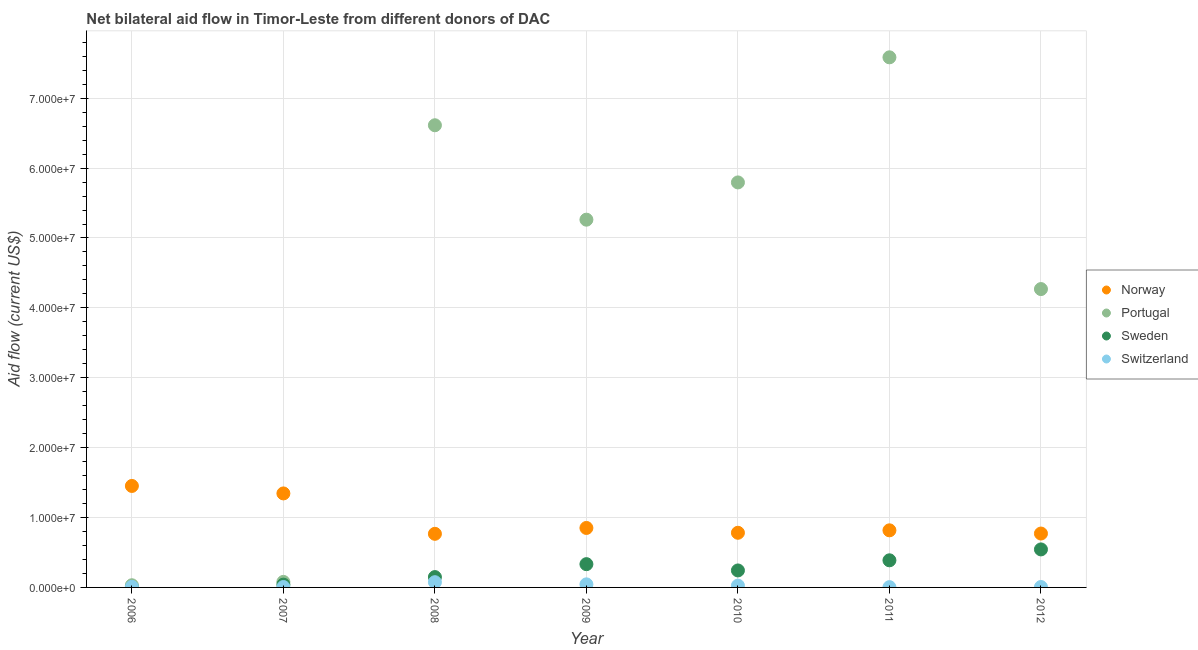What is the amount of aid given by norway in 2012?
Ensure brevity in your answer.  7.71e+06. Across all years, what is the maximum amount of aid given by portugal?
Your answer should be very brief. 7.58e+07. Across all years, what is the minimum amount of aid given by sweden?
Offer a very short reply. 10000. In which year was the amount of aid given by portugal minimum?
Provide a short and direct response. 2006. What is the total amount of aid given by norway in the graph?
Provide a succinct answer. 6.78e+07. What is the difference between the amount of aid given by portugal in 2007 and that in 2012?
Keep it short and to the point. -4.19e+07. What is the difference between the amount of aid given by switzerland in 2006 and the amount of aid given by portugal in 2009?
Ensure brevity in your answer.  -5.25e+07. What is the average amount of aid given by portugal per year?
Your answer should be very brief. 4.23e+07. In the year 2010, what is the difference between the amount of aid given by sweden and amount of aid given by norway?
Provide a short and direct response. -5.39e+06. What is the ratio of the amount of aid given by switzerland in 2011 to that in 2012?
Provide a succinct answer. 0.67. What is the difference between the highest and the second highest amount of aid given by norway?
Offer a terse response. 1.07e+06. What is the difference between the highest and the lowest amount of aid given by switzerland?
Give a very brief answer. 7.10e+05. In how many years, is the amount of aid given by switzerland greater than the average amount of aid given by switzerland taken over all years?
Make the answer very short. 3. Is it the case that in every year, the sum of the amount of aid given by norway and amount of aid given by portugal is greater than the amount of aid given by sweden?
Make the answer very short. Yes. What is the difference between two consecutive major ticks on the Y-axis?
Your response must be concise. 1.00e+07. Does the graph contain grids?
Make the answer very short. Yes. Where does the legend appear in the graph?
Give a very brief answer. Center right. How many legend labels are there?
Give a very brief answer. 4. What is the title of the graph?
Give a very brief answer. Net bilateral aid flow in Timor-Leste from different donors of DAC. What is the label or title of the Y-axis?
Your answer should be compact. Aid flow (current US$). What is the Aid flow (current US$) in Norway in 2006?
Your answer should be very brief. 1.45e+07. What is the Aid flow (current US$) of Sweden in 2006?
Your answer should be compact. 10000. What is the Aid flow (current US$) in Switzerland in 2006?
Provide a short and direct response. 9.00e+04. What is the Aid flow (current US$) in Norway in 2007?
Offer a very short reply. 1.34e+07. What is the Aid flow (current US$) in Portugal in 2007?
Provide a succinct answer. 7.90e+05. What is the Aid flow (current US$) of Switzerland in 2007?
Keep it short and to the point. 6.00e+04. What is the Aid flow (current US$) of Norway in 2008?
Your answer should be very brief. 7.67e+06. What is the Aid flow (current US$) of Portugal in 2008?
Make the answer very short. 6.61e+07. What is the Aid flow (current US$) in Sweden in 2008?
Offer a terse response. 1.48e+06. What is the Aid flow (current US$) in Switzerland in 2008?
Your answer should be compact. 7.50e+05. What is the Aid flow (current US$) of Norway in 2009?
Ensure brevity in your answer.  8.51e+06. What is the Aid flow (current US$) in Portugal in 2009?
Offer a very short reply. 5.26e+07. What is the Aid flow (current US$) of Sweden in 2009?
Keep it short and to the point. 3.33e+06. What is the Aid flow (current US$) of Switzerland in 2009?
Provide a succinct answer. 4.40e+05. What is the Aid flow (current US$) in Norway in 2010?
Keep it short and to the point. 7.82e+06. What is the Aid flow (current US$) in Portugal in 2010?
Offer a very short reply. 5.80e+07. What is the Aid flow (current US$) in Sweden in 2010?
Your response must be concise. 2.43e+06. What is the Aid flow (current US$) in Norway in 2011?
Provide a short and direct response. 8.17e+06. What is the Aid flow (current US$) in Portugal in 2011?
Your answer should be very brief. 7.58e+07. What is the Aid flow (current US$) in Sweden in 2011?
Your response must be concise. 3.88e+06. What is the Aid flow (current US$) of Switzerland in 2011?
Your answer should be compact. 4.00e+04. What is the Aid flow (current US$) in Norway in 2012?
Offer a terse response. 7.71e+06. What is the Aid flow (current US$) of Portugal in 2012?
Make the answer very short. 4.27e+07. What is the Aid flow (current US$) in Sweden in 2012?
Offer a terse response. 5.44e+06. Across all years, what is the maximum Aid flow (current US$) of Norway?
Offer a terse response. 1.45e+07. Across all years, what is the maximum Aid flow (current US$) of Portugal?
Offer a terse response. 7.58e+07. Across all years, what is the maximum Aid flow (current US$) in Sweden?
Make the answer very short. 5.44e+06. Across all years, what is the maximum Aid flow (current US$) of Switzerland?
Give a very brief answer. 7.50e+05. Across all years, what is the minimum Aid flow (current US$) in Norway?
Make the answer very short. 7.67e+06. Across all years, what is the minimum Aid flow (current US$) in Portugal?
Provide a short and direct response. 3.10e+05. Across all years, what is the minimum Aid flow (current US$) of Sweden?
Offer a very short reply. 10000. What is the total Aid flow (current US$) in Norway in the graph?
Offer a terse response. 6.78e+07. What is the total Aid flow (current US$) in Portugal in the graph?
Keep it short and to the point. 2.96e+08. What is the total Aid flow (current US$) of Sweden in the graph?
Offer a very short reply. 1.70e+07. What is the total Aid flow (current US$) of Switzerland in the graph?
Offer a terse response. 1.70e+06. What is the difference between the Aid flow (current US$) in Norway in 2006 and that in 2007?
Give a very brief answer. 1.07e+06. What is the difference between the Aid flow (current US$) in Portugal in 2006 and that in 2007?
Your response must be concise. -4.80e+05. What is the difference between the Aid flow (current US$) of Sweden in 2006 and that in 2007?
Provide a short and direct response. -3.90e+05. What is the difference between the Aid flow (current US$) of Norway in 2006 and that in 2008?
Your answer should be compact. 6.85e+06. What is the difference between the Aid flow (current US$) in Portugal in 2006 and that in 2008?
Keep it short and to the point. -6.58e+07. What is the difference between the Aid flow (current US$) of Sweden in 2006 and that in 2008?
Provide a succinct answer. -1.47e+06. What is the difference between the Aid flow (current US$) in Switzerland in 2006 and that in 2008?
Your response must be concise. -6.60e+05. What is the difference between the Aid flow (current US$) in Norway in 2006 and that in 2009?
Provide a succinct answer. 6.01e+06. What is the difference between the Aid flow (current US$) in Portugal in 2006 and that in 2009?
Your response must be concise. -5.23e+07. What is the difference between the Aid flow (current US$) of Sweden in 2006 and that in 2009?
Offer a very short reply. -3.32e+06. What is the difference between the Aid flow (current US$) in Switzerland in 2006 and that in 2009?
Ensure brevity in your answer.  -3.50e+05. What is the difference between the Aid flow (current US$) in Norway in 2006 and that in 2010?
Offer a very short reply. 6.70e+06. What is the difference between the Aid flow (current US$) in Portugal in 2006 and that in 2010?
Offer a very short reply. -5.76e+07. What is the difference between the Aid flow (current US$) in Sweden in 2006 and that in 2010?
Your response must be concise. -2.42e+06. What is the difference between the Aid flow (current US$) in Switzerland in 2006 and that in 2010?
Your answer should be compact. -1.70e+05. What is the difference between the Aid flow (current US$) in Norway in 2006 and that in 2011?
Your answer should be very brief. 6.35e+06. What is the difference between the Aid flow (current US$) in Portugal in 2006 and that in 2011?
Your response must be concise. -7.55e+07. What is the difference between the Aid flow (current US$) of Sweden in 2006 and that in 2011?
Give a very brief answer. -3.87e+06. What is the difference between the Aid flow (current US$) of Switzerland in 2006 and that in 2011?
Keep it short and to the point. 5.00e+04. What is the difference between the Aid flow (current US$) of Norway in 2006 and that in 2012?
Your response must be concise. 6.81e+06. What is the difference between the Aid flow (current US$) in Portugal in 2006 and that in 2012?
Your answer should be very brief. -4.24e+07. What is the difference between the Aid flow (current US$) of Sweden in 2006 and that in 2012?
Give a very brief answer. -5.43e+06. What is the difference between the Aid flow (current US$) in Switzerland in 2006 and that in 2012?
Your answer should be very brief. 3.00e+04. What is the difference between the Aid flow (current US$) in Norway in 2007 and that in 2008?
Make the answer very short. 5.78e+06. What is the difference between the Aid flow (current US$) in Portugal in 2007 and that in 2008?
Offer a very short reply. -6.53e+07. What is the difference between the Aid flow (current US$) in Sweden in 2007 and that in 2008?
Offer a terse response. -1.08e+06. What is the difference between the Aid flow (current US$) of Switzerland in 2007 and that in 2008?
Keep it short and to the point. -6.90e+05. What is the difference between the Aid flow (current US$) in Norway in 2007 and that in 2009?
Provide a succinct answer. 4.94e+06. What is the difference between the Aid flow (current US$) in Portugal in 2007 and that in 2009?
Give a very brief answer. -5.18e+07. What is the difference between the Aid flow (current US$) in Sweden in 2007 and that in 2009?
Give a very brief answer. -2.93e+06. What is the difference between the Aid flow (current US$) of Switzerland in 2007 and that in 2009?
Offer a very short reply. -3.80e+05. What is the difference between the Aid flow (current US$) in Norway in 2007 and that in 2010?
Provide a short and direct response. 5.63e+06. What is the difference between the Aid flow (current US$) in Portugal in 2007 and that in 2010?
Your answer should be compact. -5.72e+07. What is the difference between the Aid flow (current US$) of Sweden in 2007 and that in 2010?
Your answer should be compact. -2.03e+06. What is the difference between the Aid flow (current US$) of Switzerland in 2007 and that in 2010?
Offer a very short reply. -2.00e+05. What is the difference between the Aid flow (current US$) in Norway in 2007 and that in 2011?
Your answer should be very brief. 5.28e+06. What is the difference between the Aid flow (current US$) in Portugal in 2007 and that in 2011?
Offer a very short reply. -7.51e+07. What is the difference between the Aid flow (current US$) in Sweden in 2007 and that in 2011?
Your answer should be compact. -3.48e+06. What is the difference between the Aid flow (current US$) in Switzerland in 2007 and that in 2011?
Make the answer very short. 2.00e+04. What is the difference between the Aid flow (current US$) in Norway in 2007 and that in 2012?
Make the answer very short. 5.74e+06. What is the difference between the Aid flow (current US$) in Portugal in 2007 and that in 2012?
Make the answer very short. -4.19e+07. What is the difference between the Aid flow (current US$) of Sweden in 2007 and that in 2012?
Give a very brief answer. -5.04e+06. What is the difference between the Aid flow (current US$) of Norway in 2008 and that in 2009?
Your answer should be compact. -8.40e+05. What is the difference between the Aid flow (current US$) of Portugal in 2008 and that in 2009?
Your response must be concise. 1.35e+07. What is the difference between the Aid flow (current US$) of Sweden in 2008 and that in 2009?
Give a very brief answer. -1.85e+06. What is the difference between the Aid flow (current US$) of Switzerland in 2008 and that in 2009?
Ensure brevity in your answer.  3.10e+05. What is the difference between the Aid flow (current US$) in Portugal in 2008 and that in 2010?
Offer a terse response. 8.18e+06. What is the difference between the Aid flow (current US$) of Sweden in 2008 and that in 2010?
Offer a terse response. -9.50e+05. What is the difference between the Aid flow (current US$) in Switzerland in 2008 and that in 2010?
Provide a short and direct response. 4.90e+05. What is the difference between the Aid flow (current US$) in Norway in 2008 and that in 2011?
Offer a very short reply. -5.00e+05. What is the difference between the Aid flow (current US$) in Portugal in 2008 and that in 2011?
Provide a succinct answer. -9.72e+06. What is the difference between the Aid flow (current US$) in Sweden in 2008 and that in 2011?
Offer a very short reply. -2.40e+06. What is the difference between the Aid flow (current US$) in Switzerland in 2008 and that in 2011?
Offer a terse response. 7.10e+05. What is the difference between the Aid flow (current US$) in Norway in 2008 and that in 2012?
Offer a terse response. -4.00e+04. What is the difference between the Aid flow (current US$) in Portugal in 2008 and that in 2012?
Keep it short and to the point. 2.34e+07. What is the difference between the Aid flow (current US$) of Sweden in 2008 and that in 2012?
Your answer should be very brief. -3.96e+06. What is the difference between the Aid flow (current US$) of Switzerland in 2008 and that in 2012?
Offer a terse response. 6.90e+05. What is the difference between the Aid flow (current US$) of Norway in 2009 and that in 2010?
Ensure brevity in your answer.  6.90e+05. What is the difference between the Aid flow (current US$) in Portugal in 2009 and that in 2010?
Keep it short and to the point. -5.33e+06. What is the difference between the Aid flow (current US$) in Switzerland in 2009 and that in 2010?
Offer a very short reply. 1.80e+05. What is the difference between the Aid flow (current US$) of Portugal in 2009 and that in 2011?
Offer a very short reply. -2.32e+07. What is the difference between the Aid flow (current US$) in Sweden in 2009 and that in 2011?
Keep it short and to the point. -5.50e+05. What is the difference between the Aid flow (current US$) in Portugal in 2009 and that in 2012?
Offer a very short reply. 9.93e+06. What is the difference between the Aid flow (current US$) of Sweden in 2009 and that in 2012?
Give a very brief answer. -2.11e+06. What is the difference between the Aid flow (current US$) in Switzerland in 2009 and that in 2012?
Your answer should be compact. 3.80e+05. What is the difference between the Aid flow (current US$) in Norway in 2010 and that in 2011?
Keep it short and to the point. -3.50e+05. What is the difference between the Aid flow (current US$) in Portugal in 2010 and that in 2011?
Your answer should be compact. -1.79e+07. What is the difference between the Aid flow (current US$) in Sweden in 2010 and that in 2011?
Your answer should be compact. -1.45e+06. What is the difference between the Aid flow (current US$) of Portugal in 2010 and that in 2012?
Provide a succinct answer. 1.53e+07. What is the difference between the Aid flow (current US$) in Sweden in 2010 and that in 2012?
Ensure brevity in your answer.  -3.01e+06. What is the difference between the Aid flow (current US$) in Switzerland in 2010 and that in 2012?
Provide a succinct answer. 2.00e+05. What is the difference between the Aid flow (current US$) in Portugal in 2011 and that in 2012?
Your answer should be compact. 3.32e+07. What is the difference between the Aid flow (current US$) of Sweden in 2011 and that in 2012?
Provide a succinct answer. -1.56e+06. What is the difference between the Aid flow (current US$) in Switzerland in 2011 and that in 2012?
Give a very brief answer. -2.00e+04. What is the difference between the Aid flow (current US$) in Norway in 2006 and the Aid flow (current US$) in Portugal in 2007?
Your answer should be very brief. 1.37e+07. What is the difference between the Aid flow (current US$) in Norway in 2006 and the Aid flow (current US$) in Sweden in 2007?
Ensure brevity in your answer.  1.41e+07. What is the difference between the Aid flow (current US$) in Norway in 2006 and the Aid flow (current US$) in Switzerland in 2007?
Your response must be concise. 1.45e+07. What is the difference between the Aid flow (current US$) of Portugal in 2006 and the Aid flow (current US$) of Sweden in 2007?
Keep it short and to the point. -9.00e+04. What is the difference between the Aid flow (current US$) of Sweden in 2006 and the Aid flow (current US$) of Switzerland in 2007?
Offer a terse response. -5.00e+04. What is the difference between the Aid flow (current US$) in Norway in 2006 and the Aid flow (current US$) in Portugal in 2008?
Keep it short and to the point. -5.16e+07. What is the difference between the Aid flow (current US$) in Norway in 2006 and the Aid flow (current US$) in Sweden in 2008?
Your response must be concise. 1.30e+07. What is the difference between the Aid flow (current US$) in Norway in 2006 and the Aid flow (current US$) in Switzerland in 2008?
Offer a very short reply. 1.38e+07. What is the difference between the Aid flow (current US$) of Portugal in 2006 and the Aid flow (current US$) of Sweden in 2008?
Offer a very short reply. -1.17e+06. What is the difference between the Aid flow (current US$) of Portugal in 2006 and the Aid flow (current US$) of Switzerland in 2008?
Your response must be concise. -4.40e+05. What is the difference between the Aid flow (current US$) of Sweden in 2006 and the Aid flow (current US$) of Switzerland in 2008?
Provide a succinct answer. -7.40e+05. What is the difference between the Aid flow (current US$) of Norway in 2006 and the Aid flow (current US$) of Portugal in 2009?
Offer a terse response. -3.81e+07. What is the difference between the Aid flow (current US$) of Norway in 2006 and the Aid flow (current US$) of Sweden in 2009?
Your answer should be very brief. 1.12e+07. What is the difference between the Aid flow (current US$) in Norway in 2006 and the Aid flow (current US$) in Switzerland in 2009?
Give a very brief answer. 1.41e+07. What is the difference between the Aid flow (current US$) in Portugal in 2006 and the Aid flow (current US$) in Sweden in 2009?
Your answer should be very brief. -3.02e+06. What is the difference between the Aid flow (current US$) in Portugal in 2006 and the Aid flow (current US$) in Switzerland in 2009?
Your answer should be compact. -1.30e+05. What is the difference between the Aid flow (current US$) in Sweden in 2006 and the Aid flow (current US$) in Switzerland in 2009?
Offer a terse response. -4.30e+05. What is the difference between the Aid flow (current US$) in Norway in 2006 and the Aid flow (current US$) in Portugal in 2010?
Offer a very short reply. -4.34e+07. What is the difference between the Aid flow (current US$) of Norway in 2006 and the Aid flow (current US$) of Sweden in 2010?
Offer a terse response. 1.21e+07. What is the difference between the Aid flow (current US$) in Norway in 2006 and the Aid flow (current US$) in Switzerland in 2010?
Provide a succinct answer. 1.43e+07. What is the difference between the Aid flow (current US$) in Portugal in 2006 and the Aid flow (current US$) in Sweden in 2010?
Your answer should be compact. -2.12e+06. What is the difference between the Aid flow (current US$) of Norway in 2006 and the Aid flow (current US$) of Portugal in 2011?
Offer a terse response. -6.13e+07. What is the difference between the Aid flow (current US$) of Norway in 2006 and the Aid flow (current US$) of Sweden in 2011?
Provide a succinct answer. 1.06e+07. What is the difference between the Aid flow (current US$) in Norway in 2006 and the Aid flow (current US$) in Switzerland in 2011?
Provide a succinct answer. 1.45e+07. What is the difference between the Aid flow (current US$) of Portugal in 2006 and the Aid flow (current US$) of Sweden in 2011?
Your answer should be compact. -3.57e+06. What is the difference between the Aid flow (current US$) of Portugal in 2006 and the Aid flow (current US$) of Switzerland in 2011?
Your answer should be very brief. 2.70e+05. What is the difference between the Aid flow (current US$) in Sweden in 2006 and the Aid flow (current US$) in Switzerland in 2011?
Ensure brevity in your answer.  -3.00e+04. What is the difference between the Aid flow (current US$) in Norway in 2006 and the Aid flow (current US$) in Portugal in 2012?
Offer a very short reply. -2.82e+07. What is the difference between the Aid flow (current US$) of Norway in 2006 and the Aid flow (current US$) of Sweden in 2012?
Offer a very short reply. 9.08e+06. What is the difference between the Aid flow (current US$) in Norway in 2006 and the Aid flow (current US$) in Switzerland in 2012?
Ensure brevity in your answer.  1.45e+07. What is the difference between the Aid flow (current US$) in Portugal in 2006 and the Aid flow (current US$) in Sweden in 2012?
Ensure brevity in your answer.  -5.13e+06. What is the difference between the Aid flow (current US$) in Portugal in 2006 and the Aid flow (current US$) in Switzerland in 2012?
Offer a very short reply. 2.50e+05. What is the difference between the Aid flow (current US$) in Sweden in 2006 and the Aid flow (current US$) in Switzerland in 2012?
Provide a succinct answer. -5.00e+04. What is the difference between the Aid flow (current US$) in Norway in 2007 and the Aid flow (current US$) in Portugal in 2008?
Offer a very short reply. -5.27e+07. What is the difference between the Aid flow (current US$) in Norway in 2007 and the Aid flow (current US$) in Sweden in 2008?
Make the answer very short. 1.20e+07. What is the difference between the Aid flow (current US$) in Norway in 2007 and the Aid flow (current US$) in Switzerland in 2008?
Your answer should be very brief. 1.27e+07. What is the difference between the Aid flow (current US$) in Portugal in 2007 and the Aid flow (current US$) in Sweden in 2008?
Provide a short and direct response. -6.90e+05. What is the difference between the Aid flow (current US$) in Portugal in 2007 and the Aid flow (current US$) in Switzerland in 2008?
Give a very brief answer. 4.00e+04. What is the difference between the Aid flow (current US$) in Sweden in 2007 and the Aid flow (current US$) in Switzerland in 2008?
Provide a short and direct response. -3.50e+05. What is the difference between the Aid flow (current US$) in Norway in 2007 and the Aid flow (current US$) in Portugal in 2009?
Your response must be concise. -3.92e+07. What is the difference between the Aid flow (current US$) in Norway in 2007 and the Aid flow (current US$) in Sweden in 2009?
Keep it short and to the point. 1.01e+07. What is the difference between the Aid flow (current US$) in Norway in 2007 and the Aid flow (current US$) in Switzerland in 2009?
Provide a succinct answer. 1.30e+07. What is the difference between the Aid flow (current US$) of Portugal in 2007 and the Aid flow (current US$) of Sweden in 2009?
Offer a terse response. -2.54e+06. What is the difference between the Aid flow (current US$) of Portugal in 2007 and the Aid flow (current US$) of Switzerland in 2009?
Ensure brevity in your answer.  3.50e+05. What is the difference between the Aid flow (current US$) in Sweden in 2007 and the Aid flow (current US$) in Switzerland in 2009?
Give a very brief answer. -4.00e+04. What is the difference between the Aid flow (current US$) in Norway in 2007 and the Aid flow (current US$) in Portugal in 2010?
Your answer should be very brief. -4.45e+07. What is the difference between the Aid flow (current US$) of Norway in 2007 and the Aid flow (current US$) of Sweden in 2010?
Provide a short and direct response. 1.10e+07. What is the difference between the Aid flow (current US$) of Norway in 2007 and the Aid flow (current US$) of Switzerland in 2010?
Give a very brief answer. 1.32e+07. What is the difference between the Aid flow (current US$) of Portugal in 2007 and the Aid flow (current US$) of Sweden in 2010?
Make the answer very short. -1.64e+06. What is the difference between the Aid flow (current US$) of Portugal in 2007 and the Aid flow (current US$) of Switzerland in 2010?
Provide a succinct answer. 5.30e+05. What is the difference between the Aid flow (current US$) in Sweden in 2007 and the Aid flow (current US$) in Switzerland in 2010?
Make the answer very short. 1.40e+05. What is the difference between the Aid flow (current US$) in Norway in 2007 and the Aid flow (current US$) in Portugal in 2011?
Make the answer very short. -6.24e+07. What is the difference between the Aid flow (current US$) in Norway in 2007 and the Aid flow (current US$) in Sweden in 2011?
Your answer should be compact. 9.57e+06. What is the difference between the Aid flow (current US$) of Norway in 2007 and the Aid flow (current US$) of Switzerland in 2011?
Your answer should be very brief. 1.34e+07. What is the difference between the Aid flow (current US$) in Portugal in 2007 and the Aid flow (current US$) in Sweden in 2011?
Your answer should be very brief. -3.09e+06. What is the difference between the Aid flow (current US$) in Portugal in 2007 and the Aid flow (current US$) in Switzerland in 2011?
Offer a very short reply. 7.50e+05. What is the difference between the Aid flow (current US$) of Norway in 2007 and the Aid flow (current US$) of Portugal in 2012?
Your answer should be compact. -2.92e+07. What is the difference between the Aid flow (current US$) of Norway in 2007 and the Aid flow (current US$) of Sweden in 2012?
Give a very brief answer. 8.01e+06. What is the difference between the Aid flow (current US$) of Norway in 2007 and the Aid flow (current US$) of Switzerland in 2012?
Offer a terse response. 1.34e+07. What is the difference between the Aid flow (current US$) of Portugal in 2007 and the Aid flow (current US$) of Sweden in 2012?
Offer a very short reply. -4.65e+06. What is the difference between the Aid flow (current US$) in Portugal in 2007 and the Aid flow (current US$) in Switzerland in 2012?
Your answer should be compact. 7.30e+05. What is the difference between the Aid flow (current US$) of Norway in 2008 and the Aid flow (current US$) of Portugal in 2009?
Give a very brief answer. -4.50e+07. What is the difference between the Aid flow (current US$) of Norway in 2008 and the Aid flow (current US$) of Sweden in 2009?
Your answer should be compact. 4.34e+06. What is the difference between the Aid flow (current US$) in Norway in 2008 and the Aid flow (current US$) in Switzerland in 2009?
Ensure brevity in your answer.  7.23e+06. What is the difference between the Aid flow (current US$) in Portugal in 2008 and the Aid flow (current US$) in Sweden in 2009?
Provide a succinct answer. 6.28e+07. What is the difference between the Aid flow (current US$) in Portugal in 2008 and the Aid flow (current US$) in Switzerland in 2009?
Make the answer very short. 6.57e+07. What is the difference between the Aid flow (current US$) of Sweden in 2008 and the Aid flow (current US$) of Switzerland in 2009?
Ensure brevity in your answer.  1.04e+06. What is the difference between the Aid flow (current US$) in Norway in 2008 and the Aid flow (current US$) in Portugal in 2010?
Make the answer very short. -5.03e+07. What is the difference between the Aid flow (current US$) of Norway in 2008 and the Aid flow (current US$) of Sweden in 2010?
Keep it short and to the point. 5.24e+06. What is the difference between the Aid flow (current US$) of Norway in 2008 and the Aid flow (current US$) of Switzerland in 2010?
Ensure brevity in your answer.  7.41e+06. What is the difference between the Aid flow (current US$) of Portugal in 2008 and the Aid flow (current US$) of Sweden in 2010?
Provide a succinct answer. 6.37e+07. What is the difference between the Aid flow (current US$) in Portugal in 2008 and the Aid flow (current US$) in Switzerland in 2010?
Make the answer very short. 6.59e+07. What is the difference between the Aid flow (current US$) in Sweden in 2008 and the Aid flow (current US$) in Switzerland in 2010?
Offer a terse response. 1.22e+06. What is the difference between the Aid flow (current US$) in Norway in 2008 and the Aid flow (current US$) in Portugal in 2011?
Keep it short and to the point. -6.82e+07. What is the difference between the Aid flow (current US$) in Norway in 2008 and the Aid flow (current US$) in Sweden in 2011?
Provide a succinct answer. 3.79e+06. What is the difference between the Aid flow (current US$) of Norway in 2008 and the Aid flow (current US$) of Switzerland in 2011?
Ensure brevity in your answer.  7.63e+06. What is the difference between the Aid flow (current US$) in Portugal in 2008 and the Aid flow (current US$) in Sweden in 2011?
Your answer should be compact. 6.22e+07. What is the difference between the Aid flow (current US$) in Portugal in 2008 and the Aid flow (current US$) in Switzerland in 2011?
Offer a very short reply. 6.61e+07. What is the difference between the Aid flow (current US$) of Sweden in 2008 and the Aid flow (current US$) of Switzerland in 2011?
Offer a very short reply. 1.44e+06. What is the difference between the Aid flow (current US$) of Norway in 2008 and the Aid flow (current US$) of Portugal in 2012?
Offer a terse response. -3.50e+07. What is the difference between the Aid flow (current US$) in Norway in 2008 and the Aid flow (current US$) in Sweden in 2012?
Your response must be concise. 2.23e+06. What is the difference between the Aid flow (current US$) in Norway in 2008 and the Aid flow (current US$) in Switzerland in 2012?
Give a very brief answer. 7.61e+06. What is the difference between the Aid flow (current US$) in Portugal in 2008 and the Aid flow (current US$) in Sweden in 2012?
Your answer should be compact. 6.07e+07. What is the difference between the Aid flow (current US$) of Portugal in 2008 and the Aid flow (current US$) of Switzerland in 2012?
Make the answer very short. 6.61e+07. What is the difference between the Aid flow (current US$) in Sweden in 2008 and the Aid flow (current US$) in Switzerland in 2012?
Offer a very short reply. 1.42e+06. What is the difference between the Aid flow (current US$) in Norway in 2009 and the Aid flow (current US$) in Portugal in 2010?
Ensure brevity in your answer.  -4.94e+07. What is the difference between the Aid flow (current US$) of Norway in 2009 and the Aid flow (current US$) of Sweden in 2010?
Provide a short and direct response. 6.08e+06. What is the difference between the Aid flow (current US$) of Norway in 2009 and the Aid flow (current US$) of Switzerland in 2010?
Provide a succinct answer. 8.25e+06. What is the difference between the Aid flow (current US$) in Portugal in 2009 and the Aid flow (current US$) in Sweden in 2010?
Your response must be concise. 5.02e+07. What is the difference between the Aid flow (current US$) of Portugal in 2009 and the Aid flow (current US$) of Switzerland in 2010?
Your answer should be very brief. 5.24e+07. What is the difference between the Aid flow (current US$) in Sweden in 2009 and the Aid flow (current US$) in Switzerland in 2010?
Provide a succinct answer. 3.07e+06. What is the difference between the Aid flow (current US$) in Norway in 2009 and the Aid flow (current US$) in Portugal in 2011?
Your answer should be very brief. -6.73e+07. What is the difference between the Aid flow (current US$) of Norway in 2009 and the Aid flow (current US$) of Sweden in 2011?
Give a very brief answer. 4.63e+06. What is the difference between the Aid flow (current US$) of Norway in 2009 and the Aid flow (current US$) of Switzerland in 2011?
Offer a very short reply. 8.47e+06. What is the difference between the Aid flow (current US$) in Portugal in 2009 and the Aid flow (current US$) in Sweden in 2011?
Give a very brief answer. 4.87e+07. What is the difference between the Aid flow (current US$) in Portugal in 2009 and the Aid flow (current US$) in Switzerland in 2011?
Offer a very short reply. 5.26e+07. What is the difference between the Aid flow (current US$) of Sweden in 2009 and the Aid flow (current US$) of Switzerland in 2011?
Give a very brief answer. 3.29e+06. What is the difference between the Aid flow (current US$) in Norway in 2009 and the Aid flow (current US$) in Portugal in 2012?
Your answer should be compact. -3.42e+07. What is the difference between the Aid flow (current US$) of Norway in 2009 and the Aid flow (current US$) of Sweden in 2012?
Provide a short and direct response. 3.07e+06. What is the difference between the Aid flow (current US$) in Norway in 2009 and the Aid flow (current US$) in Switzerland in 2012?
Offer a terse response. 8.45e+06. What is the difference between the Aid flow (current US$) in Portugal in 2009 and the Aid flow (current US$) in Sweden in 2012?
Ensure brevity in your answer.  4.72e+07. What is the difference between the Aid flow (current US$) of Portugal in 2009 and the Aid flow (current US$) of Switzerland in 2012?
Your answer should be compact. 5.26e+07. What is the difference between the Aid flow (current US$) in Sweden in 2009 and the Aid flow (current US$) in Switzerland in 2012?
Provide a short and direct response. 3.27e+06. What is the difference between the Aid flow (current US$) in Norway in 2010 and the Aid flow (current US$) in Portugal in 2011?
Your answer should be compact. -6.80e+07. What is the difference between the Aid flow (current US$) in Norway in 2010 and the Aid flow (current US$) in Sweden in 2011?
Your answer should be very brief. 3.94e+06. What is the difference between the Aid flow (current US$) of Norway in 2010 and the Aid flow (current US$) of Switzerland in 2011?
Make the answer very short. 7.78e+06. What is the difference between the Aid flow (current US$) in Portugal in 2010 and the Aid flow (current US$) in Sweden in 2011?
Offer a very short reply. 5.41e+07. What is the difference between the Aid flow (current US$) in Portugal in 2010 and the Aid flow (current US$) in Switzerland in 2011?
Offer a terse response. 5.79e+07. What is the difference between the Aid flow (current US$) of Sweden in 2010 and the Aid flow (current US$) of Switzerland in 2011?
Provide a short and direct response. 2.39e+06. What is the difference between the Aid flow (current US$) in Norway in 2010 and the Aid flow (current US$) in Portugal in 2012?
Provide a succinct answer. -3.49e+07. What is the difference between the Aid flow (current US$) of Norway in 2010 and the Aid flow (current US$) of Sweden in 2012?
Offer a terse response. 2.38e+06. What is the difference between the Aid flow (current US$) of Norway in 2010 and the Aid flow (current US$) of Switzerland in 2012?
Offer a very short reply. 7.76e+06. What is the difference between the Aid flow (current US$) in Portugal in 2010 and the Aid flow (current US$) in Sweden in 2012?
Provide a succinct answer. 5.25e+07. What is the difference between the Aid flow (current US$) of Portugal in 2010 and the Aid flow (current US$) of Switzerland in 2012?
Your response must be concise. 5.79e+07. What is the difference between the Aid flow (current US$) of Sweden in 2010 and the Aid flow (current US$) of Switzerland in 2012?
Make the answer very short. 2.37e+06. What is the difference between the Aid flow (current US$) of Norway in 2011 and the Aid flow (current US$) of Portugal in 2012?
Make the answer very short. -3.45e+07. What is the difference between the Aid flow (current US$) of Norway in 2011 and the Aid flow (current US$) of Sweden in 2012?
Offer a terse response. 2.73e+06. What is the difference between the Aid flow (current US$) in Norway in 2011 and the Aid flow (current US$) in Switzerland in 2012?
Provide a succinct answer. 8.11e+06. What is the difference between the Aid flow (current US$) in Portugal in 2011 and the Aid flow (current US$) in Sweden in 2012?
Your answer should be compact. 7.04e+07. What is the difference between the Aid flow (current US$) in Portugal in 2011 and the Aid flow (current US$) in Switzerland in 2012?
Ensure brevity in your answer.  7.58e+07. What is the difference between the Aid flow (current US$) of Sweden in 2011 and the Aid flow (current US$) of Switzerland in 2012?
Your response must be concise. 3.82e+06. What is the average Aid flow (current US$) of Norway per year?
Provide a succinct answer. 9.69e+06. What is the average Aid flow (current US$) in Portugal per year?
Provide a short and direct response. 4.23e+07. What is the average Aid flow (current US$) in Sweden per year?
Your answer should be compact. 2.42e+06. What is the average Aid flow (current US$) of Switzerland per year?
Keep it short and to the point. 2.43e+05. In the year 2006, what is the difference between the Aid flow (current US$) of Norway and Aid flow (current US$) of Portugal?
Your response must be concise. 1.42e+07. In the year 2006, what is the difference between the Aid flow (current US$) of Norway and Aid flow (current US$) of Sweden?
Offer a terse response. 1.45e+07. In the year 2006, what is the difference between the Aid flow (current US$) of Norway and Aid flow (current US$) of Switzerland?
Provide a short and direct response. 1.44e+07. In the year 2006, what is the difference between the Aid flow (current US$) of Portugal and Aid flow (current US$) of Sweden?
Provide a short and direct response. 3.00e+05. In the year 2006, what is the difference between the Aid flow (current US$) in Portugal and Aid flow (current US$) in Switzerland?
Ensure brevity in your answer.  2.20e+05. In the year 2007, what is the difference between the Aid flow (current US$) in Norway and Aid flow (current US$) in Portugal?
Your answer should be very brief. 1.27e+07. In the year 2007, what is the difference between the Aid flow (current US$) of Norway and Aid flow (current US$) of Sweden?
Ensure brevity in your answer.  1.30e+07. In the year 2007, what is the difference between the Aid flow (current US$) in Norway and Aid flow (current US$) in Switzerland?
Give a very brief answer. 1.34e+07. In the year 2007, what is the difference between the Aid flow (current US$) in Portugal and Aid flow (current US$) in Switzerland?
Provide a succinct answer. 7.30e+05. In the year 2008, what is the difference between the Aid flow (current US$) of Norway and Aid flow (current US$) of Portugal?
Give a very brief answer. -5.85e+07. In the year 2008, what is the difference between the Aid flow (current US$) of Norway and Aid flow (current US$) of Sweden?
Keep it short and to the point. 6.19e+06. In the year 2008, what is the difference between the Aid flow (current US$) of Norway and Aid flow (current US$) of Switzerland?
Provide a succinct answer. 6.92e+06. In the year 2008, what is the difference between the Aid flow (current US$) of Portugal and Aid flow (current US$) of Sweden?
Your response must be concise. 6.46e+07. In the year 2008, what is the difference between the Aid flow (current US$) of Portugal and Aid flow (current US$) of Switzerland?
Your answer should be very brief. 6.54e+07. In the year 2008, what is the difference between the Aid flow (current US$) in Sweden and Aid flow (current US$) in Switzerland?
Ensure brevity in your answer.  7.30e+05. In the year 2009, what is the difference between the Aid flow (current US$) in Norway and Aid flow (current US$) in Portugal?
Provide a short and direct response. -4.41e+07. In the year 2009, what is the difference between the Aid flow (current US$) in Norway and Aid flow (current US$) in Sweden?
Your answer should be very brief. 5.18e+06. In the year 2009, what is the difference between the Aid flow (current US$) in Norway and Aid flow (current US$) in Switzerland?
Ensure brevity in your answer.  8.07e+06. In the year 2009, what is the difference between the Aid flow (current US$) in Portugal and Aid flow (current US$) in Sweden?
Keep it short and to the point. 4.93e+07. In the year 2009, what is the difference between the Aid flow (current US$) of Portugal and Aid flow (current US$) of Switzerland?
Keep it short and to the point. 5.22e+07. In the year 2009, what is the difference between the Aid flow (current US$) in Sweden and Aid flow (current US$) in Switzerland?
Offer a very short reply. 2.89e+06. In the year 2010, what is the difference between the Aid flow (current US$) in Norway and Aid flow (current US$) in Portugal?
Provide a short and direct response. -5.01e+07. In the year 2010, what is the difference between the Aid flow (current US$) of Norway and Aid flow (current US$) of Sweden?
Offer a terse response. 5.39e+06. In the year 2010, what is the difference between the Aid flow (current US$) of Norway and Aid flow (current US$) of Switzerland?
Make the answer very short. 7.56e+06. In the year 2010, what is the difference between the Aid flow (current US$) in Portugal and Aid flow (current US$) in Sweden?
Keep it short and to the point. 5.55e+07. In the year 2010, what is the difference between the Aid flow (current US$) in Portugal and Aid flow (current US$) in Switzerland?
Your answer should be compact. 5.77e+07. In the year 2010, what is the difference between the Aid flow (current US$) of Sweden and Aid flow (current US$) of Switzerland?
Ensure brevity in your answer.  2.17e+06. In the year 2011, what is the difference between the Aid flow (current US$) of Norway and Aid flow (current US$) of Portugal?
Give a very brief answer. -6.77e+07. In the year 2011, what is the difference between the Aid flow (current US$) in Norway and Aid flow (current US$) in Sweden?
Offer a terse response. 4.29e+06. In the year 2011, what is the difference between the Aid flow (current US$) in Norway and Aid flow (current US$) in Switzerland?
Keep it short and to the point. 8.13e+06. In the year 2011, what is the difference between the Aid flow (current US$) of Portugal and Aid flow (current US$) of Sweden?
Make the answer very short. 7.20e+07. In the year 2011, what is the difference between the Aid flow (current US$) of Portugal and Aid flow (current US$) of Switzerland?
Offer a terse response. 7.58e+07. In the year 2011, what is the difference between the Aid flow (current US$) of Sweden and Aid flow (current US$) of Switzerland?
Give a very brief answer. 3.84e+06. In the year 2012, what is the difference between the Aid flow (current US$) of Norway and Aid flow (current US$) of Portugal?
Give a very brief answer. -3.50e+07. In the year 2012, what is the difference between the Aid flow (current US$) of Norway and Aid flow (current US$) of Sweden?
Provide a succinct answer. 2.27e+06. In the year 2012, what is the difference between the Aid flow (current US$) in Norway and Aid flow (current US$) in Switzerland?
Provide a short and direct response. 7.65e+06. In the year 2012, what is the difference between the Aid flow (current US$) in Portugal and Aid flow (current US$) in Sweden?
Offer a terse response. 3.72e+07. In the year 2012, what is the difference between the Aid flow (current US$) in Portugal and Aid flow (current US$) in Switzerland?
Provide a succinct answer. 4.26e+07. In the year 2012, what is the difference between the Aid flow (current US$) in Sweden and Aid flow (current US$) in Switzerland?
Offer a very short reply. 5.38e+06. What is the ratio of the Aid flow (current US$) in Norway in 2006 to that in 2007?
Offer a terse response. 1.08. What is the ratio of the Aid flow (current US$) in Portugal in 2006 to that in 2007?
Make the answer very short. 0.39. What is the ratio of the Aid flow (current US$) of Sweden in 2006 to that in 2007?
Your answer should be compact. 0.03. What is the ratio of the Aid flow (current US$) of Norway in 2006 to that in 2008?
Ensure brevity in your answer.  1.89. What is the ratio of the Aid flow (current US$) of Portugal in 2006 to that in 2008?
Give a very brief answer. 0. What is the ratio of the Aid flow (current US$) in Sweden in 2006 to that in 2008?
Make the answer very short. 0.01. What is the ratio of the Aid flow (current US$) of Switzerland in 2006 to that in 2008?
Give a very brief answer. 0.12. What is the ratio of the Aid flow (current US$) in Norway in 2006 to that in 2009?
Make the answer very short. 1.71. What is the ratio of the Aid flow (current US$) of Portugal in 2006 to that in 2009?
Offer a very short reply. 0.01. What is the ratio of the Aid flow (current US$) of Sweden in 2006 to that in 2009?
Give a very brief answer. 0. What is the ratio of the Aid flow (current US$) in Switzerland in 2006 to that in 2009?
Your answer should be compact. 0.2. What is the ratio of the Aid flow (current US$) of Norway in 2006 to that in 2010?
Offer a very short reply. 1.86. What is the ratio of the Aid flow (current US$) in Portugal in 2006 to that in 2010?
Provide a short and direct response. 0.01. What is the ratio of the Aid flow (current US$) in Sweden in 2006 to that in 2010?
Ensure brevity in your answer.  0. What is the ratio of the Aid flow (current US$) in Switzerland in 2006 to that in 2010?
Give a very brief answer. 0.35. What is the ratio of the Aid flow (current US$) of Norway in 2006 to that in 2011?
Offer a very short reply. 1.78. What is the ratio of the Aid flow (current US$) of Portugal in 2006 to that in 2011?
Give a very brief answer. 0. What is the ratio of the Aid flow (current US$) of Sweden in 2006 to that in 2011?
Provide a succinct answer. 0. What is the ratio of the Aid flow (current US$) of Switzerland in 2006 to that in 2011?
Provide a succinct answer. 2.25. What is the ratio of the Aid flow (current US$) of Norway in 2006 to that in 2012?
Offer a terse response. 1.88. What is the ratio of the Aid flow (current US$) of Portugal in 2006 to that in 2012?
Your answer should be very brief. 0.01. What is the ratio of the Aid flow (current US$) in Sweden in 2006 to that in 2012?
Your answer should be very brief. 0. What is the ratio of the Aid flow (current US$) of Switzerland in 2006 to that in 2012?
Your answer should be very brief. 1.5. What is the ratio of the Aid flow (current US$) in Norway in 2007 to that in 2008?
Provide a short and direct response. 1.75. What is the ratio of the Aid flow (current US$) of Portugal in 2007 to that in 2008?
Your answer should be very brief. 0.01. What is the ratio of the Aid flow (current US$) in Sweden in 2007 to that in 2008?
Your answer should be compact. 0.27. What is the ratio of the Aid flow (current US$) in Switzerland in 2007 to that in 2008?
Keep it short and to the point. 0.08. What is the ratio of the Aid flow (current US$) of Norway in 2007 to that in 2009?
Ensure brevity in your answer.  1.58. What is the ratio of the Aid flow (current US$) in Portugal in 2007 to that in 2009?
Provide a short and direct response. 0.01. What is the ratio of the Aid flow (current US$) in Sweden in 2007 to that in 2009?
Give a very brief answer. 0.12. What is the ratio of the Aid flow (current US$) in Switzerland in 2007 to that in 2009?
Provide a succinct answer. 0.14. What is the ratio of the Aid flow (current US$) of Norway in 2007 to that in 2010?
Give a very brief answer. 1.72. What is the ratio of the Aid flow (current US$) in Portugal in 2007 to that in 2010?
Offer a very short reply. 0.01. What is the ratio of the Aid flow (current US$) in Sweden in 2007 to that in 2010?
Give a very brief answer. 0.16. What is the ratio of the Aid flow (current US$) of Switzerland in 2007 to that in 2010?
Ensure brevity in your answer.  0.23. What is the ratio of the Aid flow (current US$) in Norway in 2007 to that in 2011?
Your answer should be very brief. 1.65. What is the ratio of the Aid flow (current US$) of Portugal in 2007 to that in 2011?
Offer a very short reply. 0.01. What is the ratio of the Aid flow (current US$) in Sweden in 2007 to that in 2011?
Provide a succinct answer. 0.1. What is the ratio of the Aid flow (current US$) of Switzerland in 2007 to that in 2011?
Your answer should be very brief. 1.5. What is the ratio of the Aid flow (current US$) in Norway in 2007 to that in 2012?
Your answer should be very brief. 1.74. What is the ratio of the Aid flow (current US$) in Portugal in 2007 to that in 2012?
Ensure brevity in your answer.  0.02. What is the ratio of the Aid flow (current US$) of Sweden in 2007 to that in 2012?
Give a very brief answer. 0.07. What is the ratio of the Aid flow (current US$) in Norway in 2008 to that in 2009?
Keep it short and to the point. 0.9. What is the ratio of the Aid flow (current US$) in Portugal in 2008 to that in 2009?
Provide a succinct answer. 1.26. What is the ratio of the Aid flow (current US$) of Sweden in 2008 to that in 2009?
Your response must be concise. 0.44. What is the ratio of the Aid flow (current US$) in Switzerland in 2008 to that in 2009?
Your answer should be very brief. 1.7. What is the ratio of the Aid flow (current US$) in Norway in 2008 to that in 2010?
Keep it short and to the point. 0.98. What is the ratio of the Aid flow (current US$) in Portugal in 2008 to that in 2010?
Give a very brief answer. 1.14. What is the ratio of the Aid flow (current US$) of Sweden in 2008 to that in 2010?
Offer a terse response. 0.61. What is the ratio of the Aid flow (current US$) in Switzerland in 2008 to that in 2010?
Provide a short and direct response. 2.88. What is the ratio of the Aid flow (current US$) in Norway in 2008 to that in 2011?
Give a very brief answer. 0.94. What is the ratio of the Aid flow (current US$) of Portugal in 2008 to that in 2011?
Make the answer very short. 0.87. What is the ratio of the Aid flow (current US$) in Sweden in 2008 to that in 2011?
Offer a terse response. 0.38. What is the ratio of the Aid flow (current US$) in Switzerland in 2008 to that in 2011?
Give a very brief answer. 18.75. What is the ratio of the Aid flow (current US$) of Norway in 2008 to that in 2012?
Your answer should be very brief. 0.99. What is the ratio of the Aid flow (current US$) of Portugal in 2008 to that in 2012?
Make the answer very short. 1.55. What is the ratio of the Aid flow (current US$) in Sweden in 2008 to that in 2012?
Provide a succinct answer. 0.27. What is the ratio of the Aid flow (current US$) of Norway in 2009 to that in 2010?
Provide a succinct answer. 1.09. What is the ratio of the Aid flow (current US$) in Portugal in 2009 to that in 2010?
Offer a terse response. 0.91. What is the ratio of the Aid flow (current US$) in Sweden in 2009 to that in 2010?
Provide a succinct answer. 1.37. What is the ratio of the Aid flow (current US$) of Switzerland in 2009 to that in 2010?
Your response must be concise. 1.69. What is the ratio of the Aid flow (current US$) in Norway in 2009 to that in 2011?
Provide a succinct answer. 1.04. What is the ratio of the Aid flow (current US$) in Portugal in 2009 to that in 2011?
Keep it short and to the point. 0.69. What is the ratio of the Aid flow (current US$) in Sweden in 2009 to that in 2011?
Offer a terse response. 0.86. What is the ratio of the Aid flow (current US$) of Switzerland in 2009 to that in 2011?
Make the answer very short. 11. What is the ratio of the Aid flow (current US$) in Norway in 2009 to that in 2012?
Provide a succinct answer. 1.1. What is the ratio of the Aid flow (current US$) of Portugal in 2009 to that in 2012?
Your response must be concise. 1.23. What is the ratio of the Aid flow (current US$) of Sweden in 2009 to that in 2012?
Offer a terse response. 0.61. What is the ratio of the Aid flow (current US$) of Switzerland in 2009 to that in 2012?
Your answer should be compact. 7.33. What is the ratio of the Aid flow (current US$) of Norway in 2010 to that in 2011?
Make the answer very short. 0.96. What is the ratio of the Aid flow (current US$) of Portugal in 2010 to that in 2011?
Your answer should be very brief. 0.76. What is the ratio of the Aid flow (current US$) in Sweden in 2010 to that in 2011?
Your response must be concise. 0.63. What is the ratio of the Aid flow (current US$) of Switzerland in 2010 to that in 2011?
Offer a terse response. 6.5. What is the ratio of the Aid flow (current US$) in Norway in 2010 to that in 2012?
Your answer should be very brief. 1.01. What is the ratio of the Aid flow (current US$) of Portugal in 2010 to that in 2012?
Your answer should be compact. 1.36. What is the ratio of the Aid flow (current US$) of Sweden in 2010 to that in 2012?
Make the answer very short. 0.45. What is the ratio of the Aid flow (current US$) of Switzerland in 2010 to that in 2012?
Your response must be concise. 4.33. What is the ratio of the Aid flow (current US$) in Norway in 2011 to that in 2012?
Provide a short and direct response. 1.06. What is the ratio of the Aid flow (current US$) of Portugal in 2011 to that in 2012?
Your answer should be compact. 1.78. What is the ratio of the Aid flow (current US$) of Sweden in 2011 to that in 2012?
Keep it short and to the point. 0.71. What is the ratio of the Aid flow (current US$) in Switzerland in 2011 to that in 2012?
Provide a short and direct response. 0.67. What is the difference between the highest and the second highest Aid flow (current US$) in Norway?
Provide a succinct answer. 1.07e+06. What is the difference between the highest and the second highest Aid flow (current US$) of Portugal?
Your response must be concise. 9.72e+06. What is the difference between the highest and the second highest Aid flow (current US$) of Sweden?
Offer a very short reply. 1.56e+06. What is the difference between the highest and the second highest Aid flow (current US$) in Switzerland?
Give a very brief answer. 3.10e+05. What is the difference between the highest and the lowest Aid flow (current US$) of Norway?
Provide a short and direct response. 6.85e+06. What is the difference between the highest and the lowest Aid flow (current US$) in Portugal?
Your answer should be compact. 7.55e+07. What is the difference between the highest and the lowest Aid flow (current US$) in Sweden?
Your answer should be very brief. 5.43e+06. What is the difference between the highest and the lowest Aid flow (current US$) of Switzerland?
Offer a terse response. 7.10e+05. 